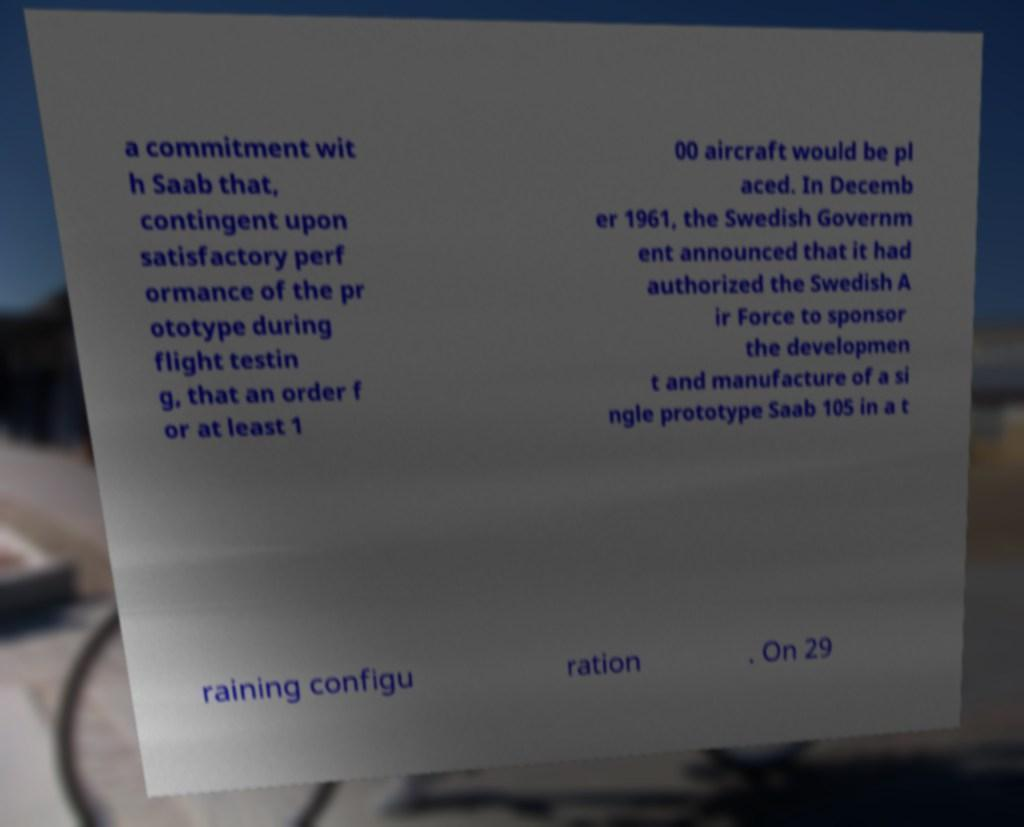Please identify and transcribe the text found in this image. a commitment wit h Saab that, contingent upon satisfactory perf ormance of the pr ototype during flight testin g, that an order f or at least 1 00 aircraft would be pl aced. In Decemb er 1961, the Swedish Governm ent announced that it had authorized the Swedish A ir Force to sponsor the developmen t and manufacture of a si ngle prototype Saab 105 in a t raining configu ration . On 29 